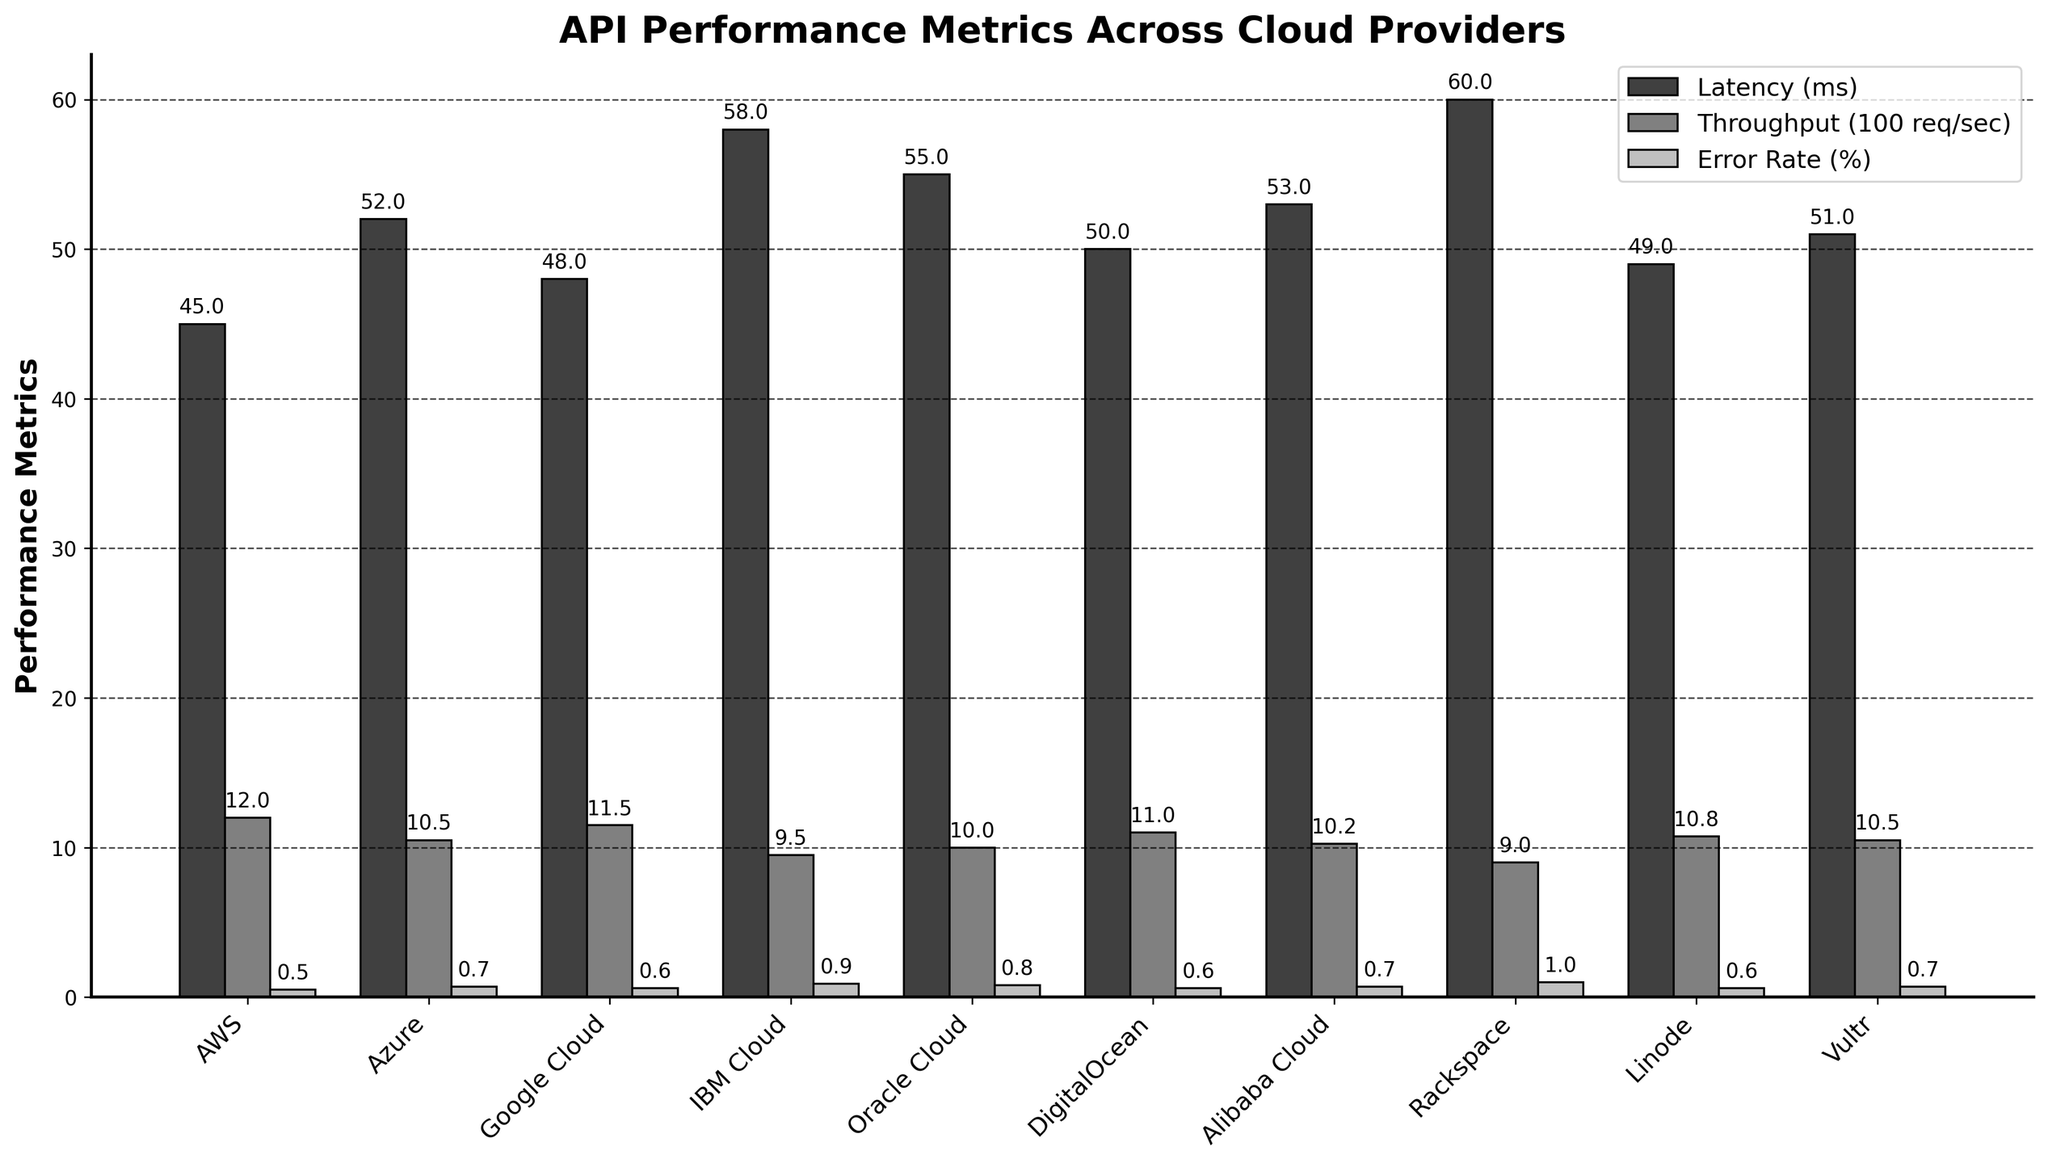What's the cloud provider with the lowest latency? To find the cloud provider with the lowest latency, look for the shortest bar in the "Latency (ms)" category. AWS has a latency of 45 ms which is the lowest.
Answer: AWS Which cloud provider has the highest error rate? To determine the cloud provider with the highest error rate, identify the tallest bar in the "Error Rate (%)" category. Rackspace has the highest error rate at 1.0%.
Answer: Rackspace What's the total throughput of AWS and Google Cloud combined? Checking the "Throughput (req/sec)" bars for AWS and Google Cloud. AWS has 1200 req/sec and Google Cloud has 1150 req/sec. Summing them is 1200 + 1150 = 2350 req/sec.
Answer: 2350 req/sec Which cloud provider has the closest error rate to DigitalOcean? Find the bar in the "Error Rate (%)" category closest to that of DigitalOcean, which is 0.6%. Similar values can be found for Google Cloud, Linode, and Alibaba Cloud.
Answer: Google Cloud, Linode, Alibaba Cloud Which cloud provider has a higher latency: Azure or Oracle Cloud? Compare the heights of the "Latency (ms)" bars for Azure (52 ms) and Oracle Cloud (55 ms). Azure's bar is shorter, indicating lower latency.
Answer: Oracle Cloud What is the difference in latency between the cloud provider with the highest and the lowest latency? Identify the highest latency (Rackspace, 60 ms) and the lowest latency (AWS, 45 ms). Subtract the lowest from the highest: 60 - 45 = 15 ms.
Answer: 15 ms What's the average throughput across all cloud providers? Sum the throughput values for all providers and divide by the total number of providers. Total throughput = 1200 + 1050 + 1150 + 950 + 1000 + 1100 + 1025 + 900 + 1075 + 1050 = 10500 req/sec. Average = 10500 / 10 = 1050 req/sec.
Answer: 1050 req/sec Which cloud providers have a throughput greater than 1100 req/sec? Look for the "Throughput (100 req/sec)" bars taller than those represented by 1100 req/sec. AWS, Google Cloud, and DigitalOcean have throughputs higher than 1100 req/sec.
Answer: AWS, Google Cloud, DigitalOcean What is the combined error rate of IBM Cloud and Rackspace? Check the "Error Rate (%)" bars for IBM Cloud (0.9%) and Rackspace (1.0%). Combined error rate = 0.9 + 1.0 = 1.9%.
Answer: 1.9% Which cloud provider has the smallest latency among Vultr, DigitalOcean, and Linode? Compare the "Latency (ms)" bars for Vultr (51 ms), DigitalOcean (50 ms), and Linode (49 ms). Linode has the smallest latency.
Answer: Linode 